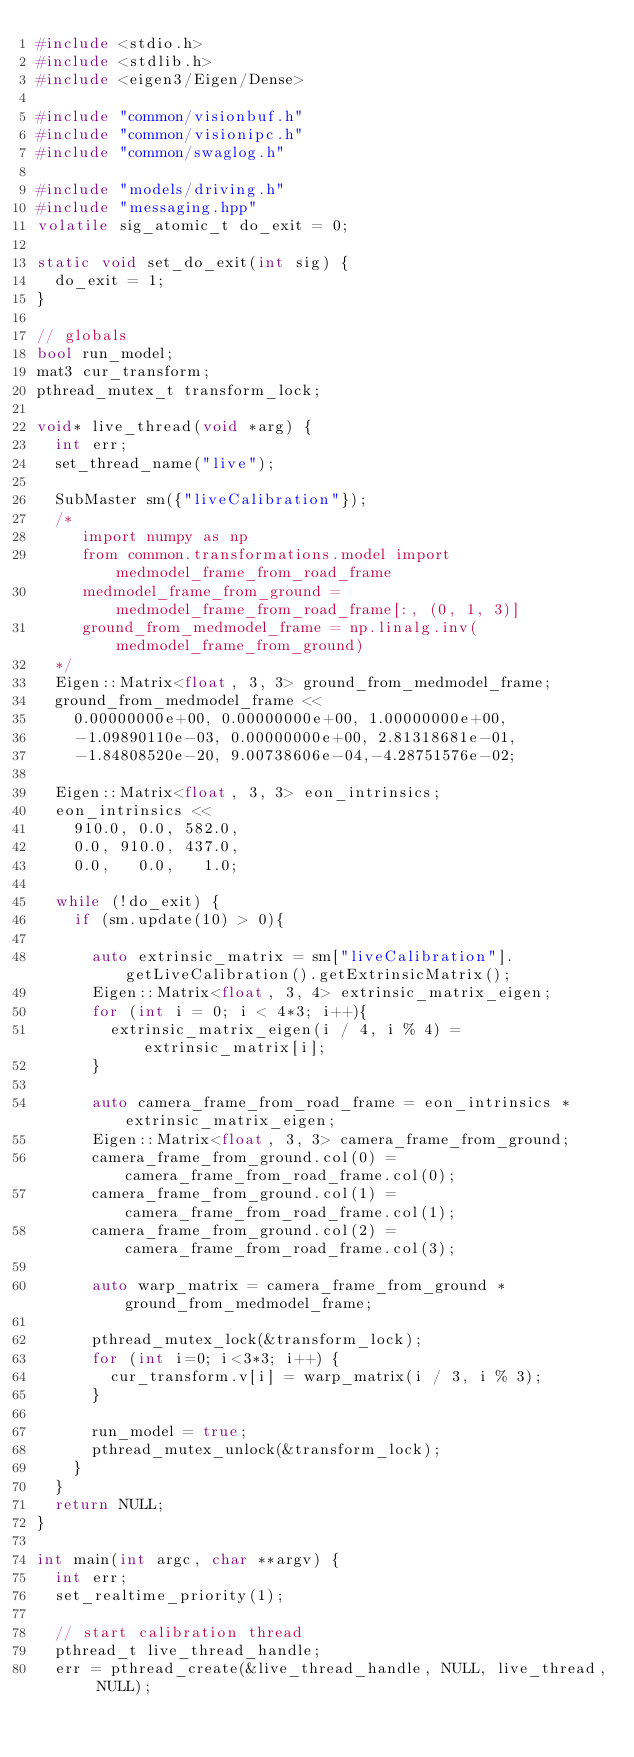<code> <loc_0><loc_0><loc_500><loc_500><_C++_>#include <stdio.h>
#include <stdlib.h>
#include <eigen3/Eigen/Dense>

#include "common/visionbuf.h"
#include "common/visionipc.h"
#include "common/swaglog.h"

#include "models/driving.h"
#include "messaging.hpp"
volatile sig_atomic_t do_exit = 0;

static void set_do_exit(int sig) {
  do_exit = 1;
}

// globals
bool run_model;
mat3 cur_transform;
pthread_mutex_t transform_lock;

void* live_thread(void *arg) {
  int err;
  set_thread_name("live");

  SubMaster sm({"liveCalibration"});
  /*
     import numpy as np
     from common.transformations.model import medmodel_frame_from_road_frame
     medmodel_frame_from_ground = medmodel_frame_from_road_frame[:, (0, 1, 3)]
     ground_from_medmodel_frame = np.linalg.inv(medmodel_frame_from_ground)
  */
  Eigen::Matrix<float, 3, 3> ground_from_medmodel_frame;
  ground_from_medmodel_frame <<
    0.00000000e+00, 0.00000000e+00, 1.00000000e+00,
    -1.09890110e-03, 0.00000000e+00, 2.81318681e-01,
    -1.84808520e-20, 9.00738606e-04,-4.28751576e-02;

  Eigen::Matrix<float, 3, 3> eon_intrinsics;
  eon_intrinsics <<
    910.0, 0.0, 582.0,
    0.0, 910.0, 437.0,
    0.0,   0.0,   1.0;

  while (!do_exit) {
    if (sm.update(10) > 0){

      auto extrinsic_matrix = sm["liveCalibration"].getLiveCalibration().getExtrinsicMatrix();
      Eigen::Matrix<float, 3, 4> extrinsic_matrix_eigen;
      for (int i = 0; i < 4*3; i++){
        extrinsic_matrix_eigen(i / 4, i % 4) = extrinsic_matrix[i];
      }

      auto camera_frame_from_road_frame = eon_intrinsics * extrinsic_matrix_eigen;
      Eigen::Matrix<float, 3, 3> camera_frame_from_ground;
      camera_frame_from_ground.col(0) = camera_frame_from_road_frame.col(0);
      camera_frame_from_ground.col(1) = camera_frame_from_road_frame.col(1);
      camera_frame_from_ground.col(2) = camera_frame_from_road_frame.col(3);

      auto warp_matrix = camera_frame_from_ground * ground_from_medmodel_frame;

      pthread_mutex_lock(&transform_lock);
      for (int i=0; i<3*3; i++) {
        cur_transform.v[i] = warp_matrix(i / 3, i % 3);
      }

      run_model = true;
      pthread_mutex_unlock(&transform_lock);
    }
  }
  return NULL;
}

int main(int argc, char **argv) {
  int err;
  set_realtime_priority(1);

  // start calibration thread
  pthread_t live_thread_handle;
  err = pthread_create(&live_thread_handle, NULL, live_thread, NULL);</code> 